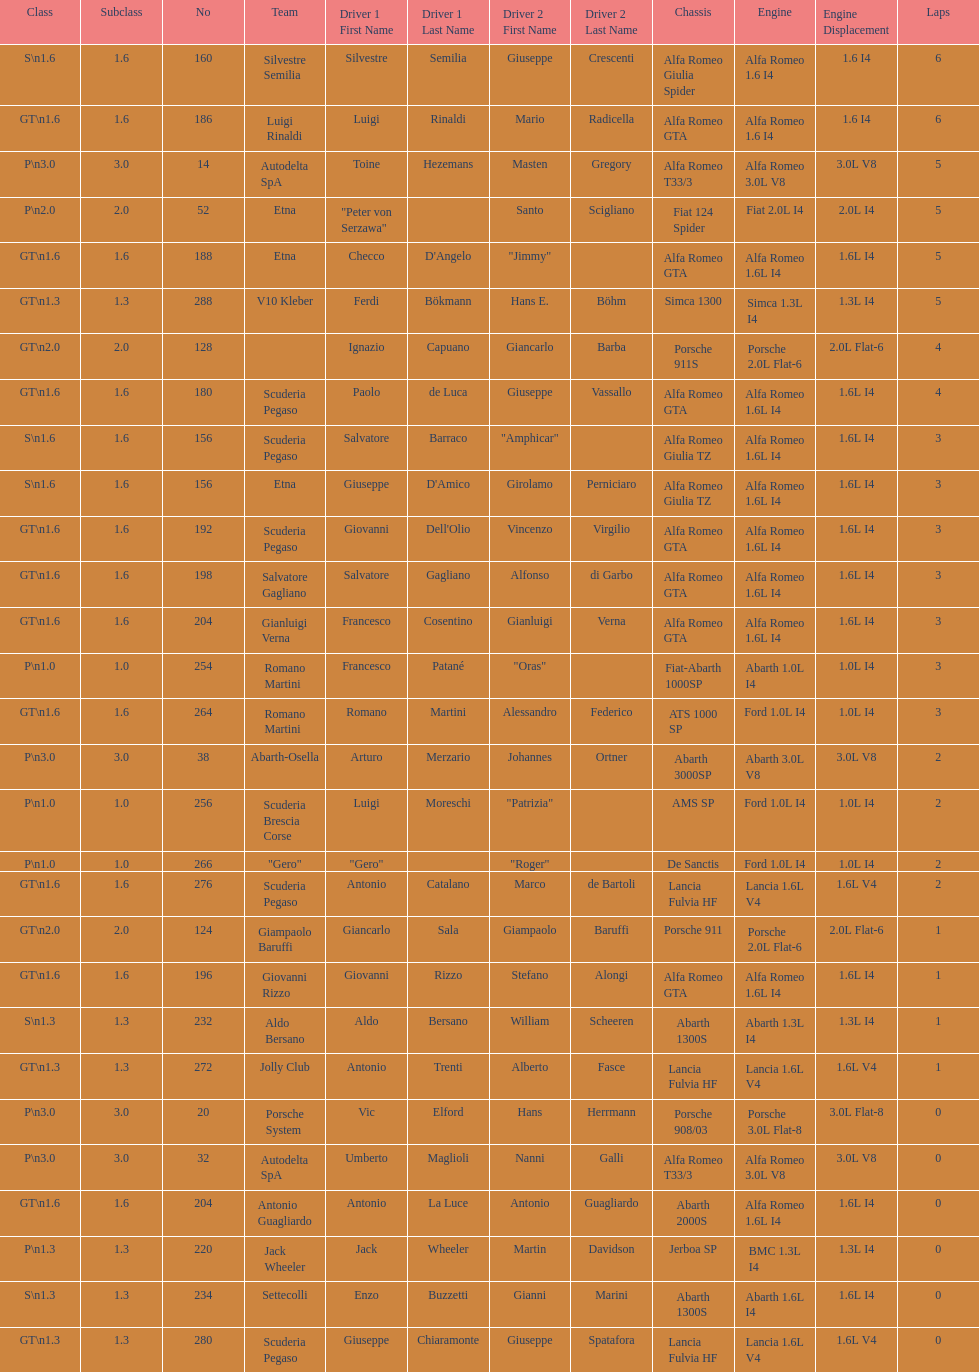Which chassis is in the middle of simca 1300 and alfa romeo gta? Porsche 911S. 